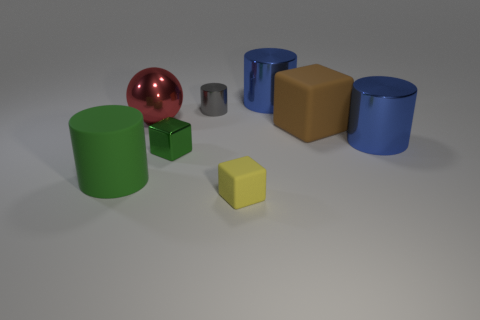What number of small objects are the same shape as the large green matte thing?
Make the answer very short. 1. There is a cube that is the same color as the rubber cylinder; what is its material?
Provide a succinct answer. Metal. There is a cylinder that is in front of the shiny block; is its size the same as the metallic cylinder in front of the tiny gray thing?
Offer a very short reply. Yes. There is a large matte object that is on the left side of the tiny yellow object; what shape is it?
Your response must be concise. Cylinder. There is a gray thing that is the same shape as the big green thing; what is its material?
Offer a very short reply. Metal. Does the yellow thing that is in front of the brown thing have the same size as the large matte block?
Give a very brief answer. No. There is a shiny sphere; what number of shiny cylinders are in front of it?
Keep it short and to the point. 1. Are there fewer green cylinders that are behind the tiny gray thing than rubber things to the left of the metallic cube?
Give a very brief answer. Yes. What number of objects are there?
Keep it short and to the point. 8. There is a big rubber object that is right of the small green metal thing; what is its color?
Offer a very short reply. Brown. 